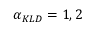Convert formula to latex. <formula><loc_0><loc_0><loc_500><loc_500>\alpha _ { K L D } = 1 , 2</formula> 